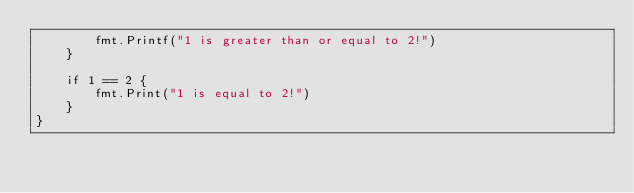Convert code to text. <code><loc_0><loc_0><loc_500><loc_500><_Go_>		fmt.Printf("1 is greater than or equal to 2!")
	}

	if 1 == 2 {
		fmt.Print("1 is equal to 2!")
	}
}
</code> 